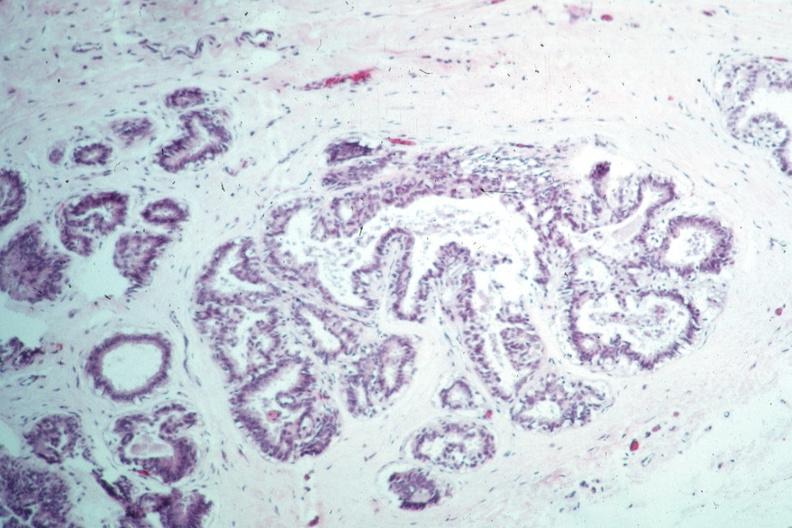does this image appear benign?
Answer the question using a single word or phrase. Yes 